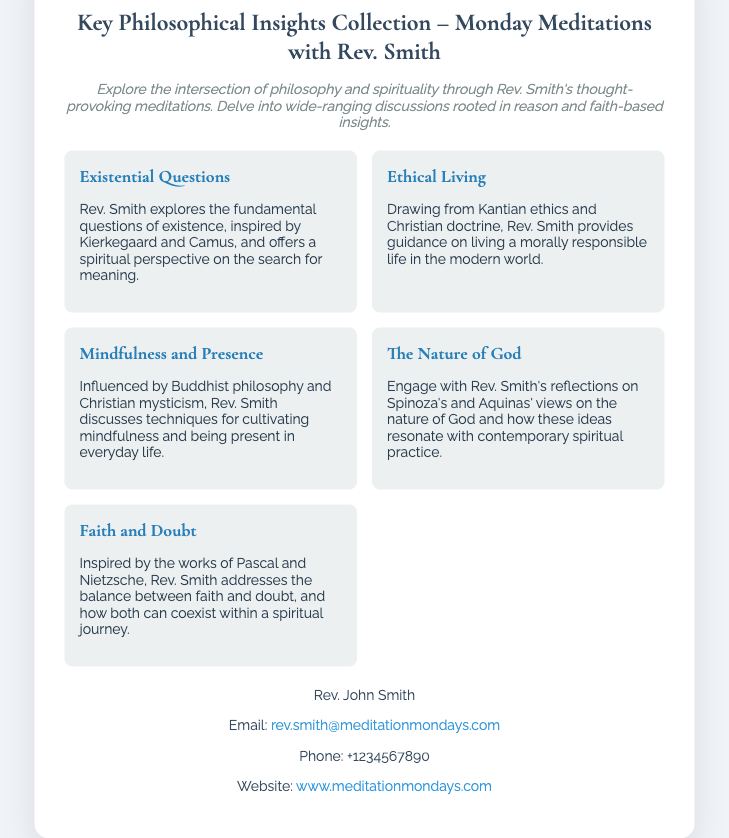What is the name of the event? The event is titled "Key Philosophical Insights Collection – Monday Meditations with Rev. Smith."
Answer: Monday Meditations with Rev. Smith Who is the host of the meditations? The host of the meditations is Rev. John Smith.
Answer: Rev. John Smith What is the primary focus of the meditations? The meditations aim to explore the intersection of philosophy and spirituality.
Answer: Intersection of philosophy and spirituality Which theme discusses the balance between faith and doubt? The theme that addresses this balance is "Faith and Doubt."
Answer: Faith and Doubt What is the email address for contact? The email address provided for contact is "rev.smith@meditationmondays.com."
Answer: rev.smith@meditationmondays.com How many themes are discussed in the meditations? There are five themes highlighted in the document.
Answer: Five What philosophical influence is mentioned in the theme about "Mindfulness and Presence"? The theme references "Buddhist philosophy and Christian mysticism."
Answer: Buddhist philosophy and Christian mysticism Which philosopher's views on the nature of God are included? The reflections include the views of "Spinoza and Aquinas."
Answer: Spinoza and Aquinas 